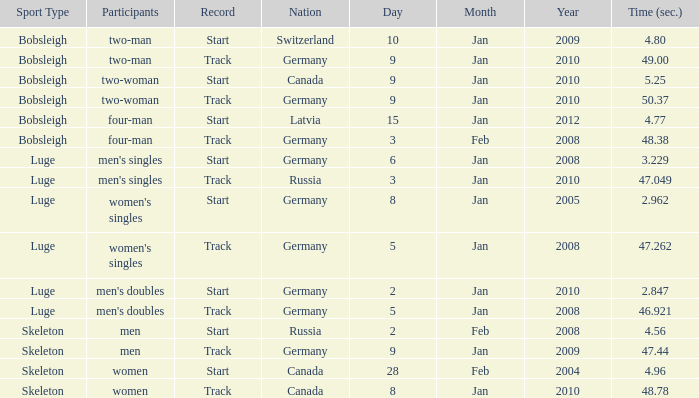Which sport has a time over 49? Bobsleigh - two-woman. 